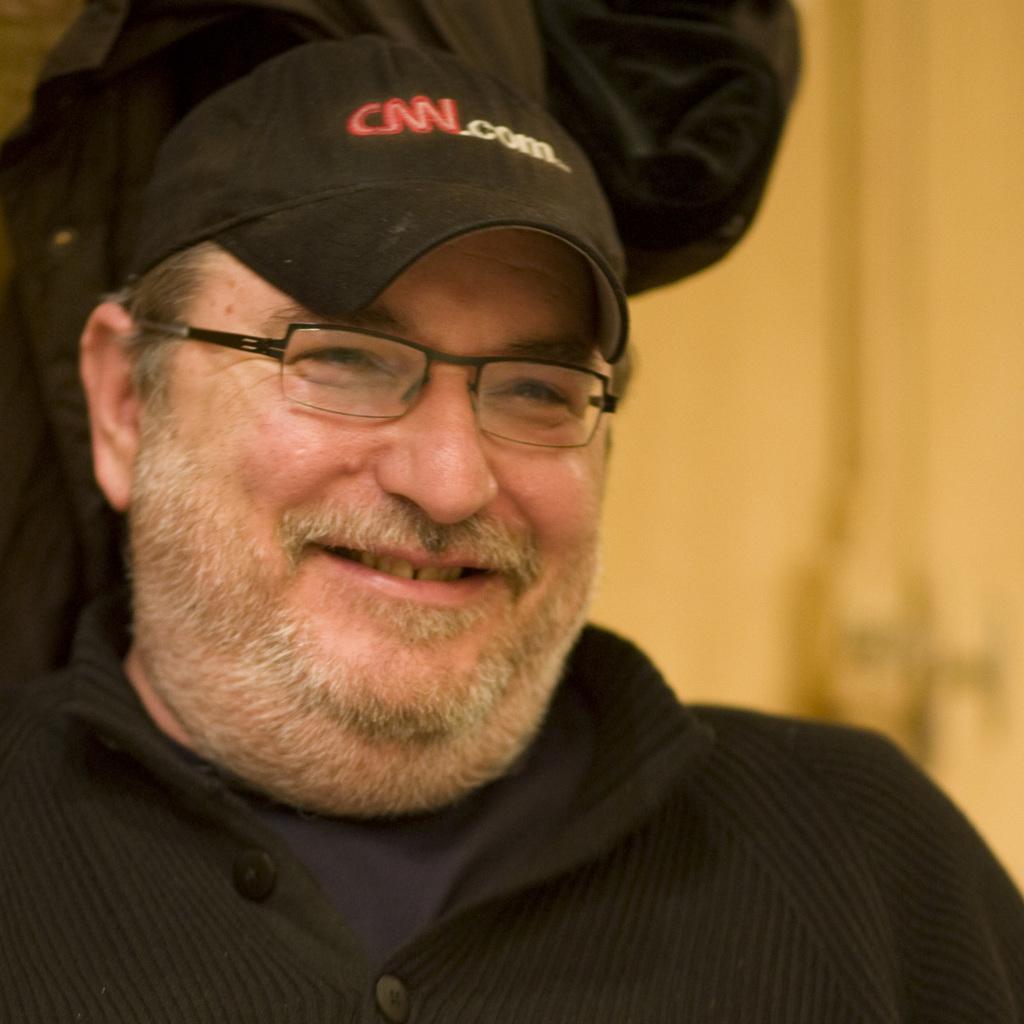Describe this image in one or two sentences. In this image we can see a man is smiling and he has spectacles to his eyes, cap on the head. In the background the image is not clear but we can see a person, objects and wall. 